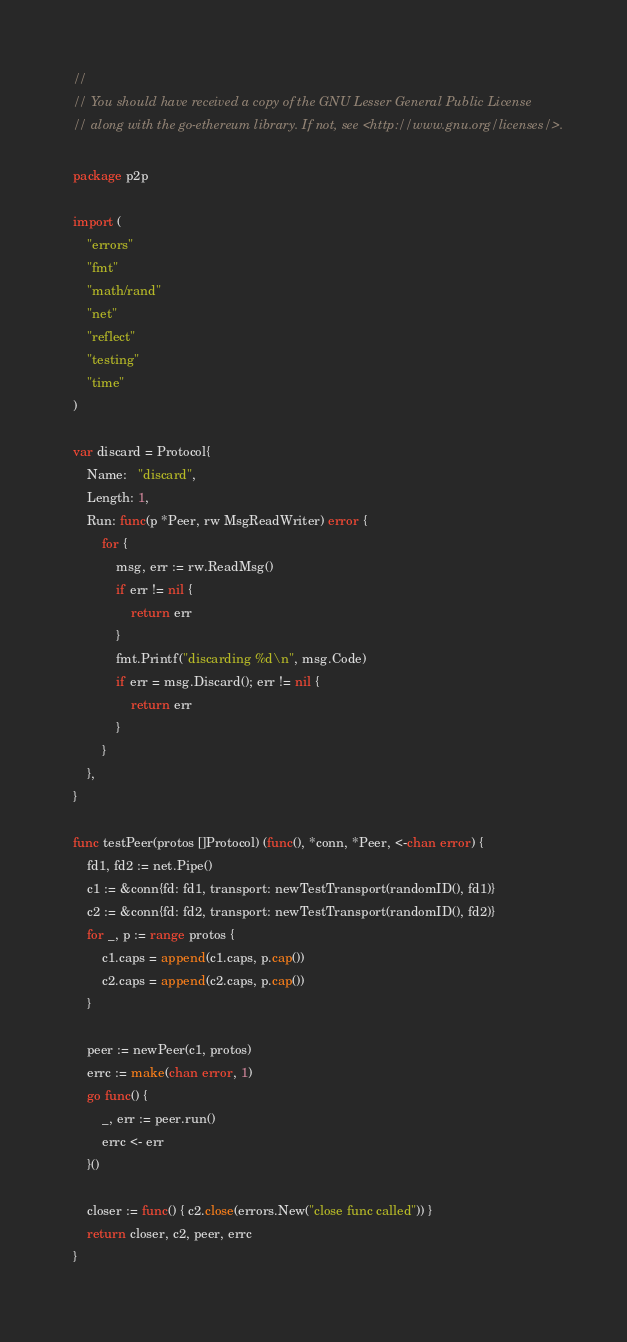Convert code to text. <code><loc_0><loc_0><loc_500><loc_500><_Go_>//
// You should have received a copy of the GNU Lesser General Public License
// along with the go-ethereum library. If not, see <http://www.gnu.org/licenses/>.

package p2p

import (
	"errors"
	"fmt"
	"math/rand"
	"net"
	"reflect"
	"testing"
	"time"
)

var discard = Protocol{
	Name:   "discard",
	Length: 1,
	Run: func(p *Peer, rw MsgReadWriter) error {
		for {
			msg, err := rw.ReadMsg()
			if err != nil {
				return err
			}
			fmt.Printf("discarding %d\n", msg.Code)
			if err = msg.Discard(); err != nil {
				return err
			}
		}
	},
}

func testPeer(protos []Protocol) (func(), *conn, *Peer, <-chan error) {
	fd1, fd2 := net.Pipe()
	c1 := &conn{fd: fd1, transport: newTestTransport(randomID(), fd1)}
	c2 := &conn{fd: fd2, transport: newTestTransport(randomID(), fd2)}
	for _, p := range protos {
		c1.caps = append(c1.caps, p.cap())
		c2.caps = append(c2.caps, p.cap())
	}

	peer := newPeer(c1, protos)
	errc := make(chan error, 1)
	go func() {
		_, err := peer.run()
		errc <- err
	}()

	closer := func() { c2.close(errors.New("close func called")) }
	return closer, c2, peer, errc
}
</code> 